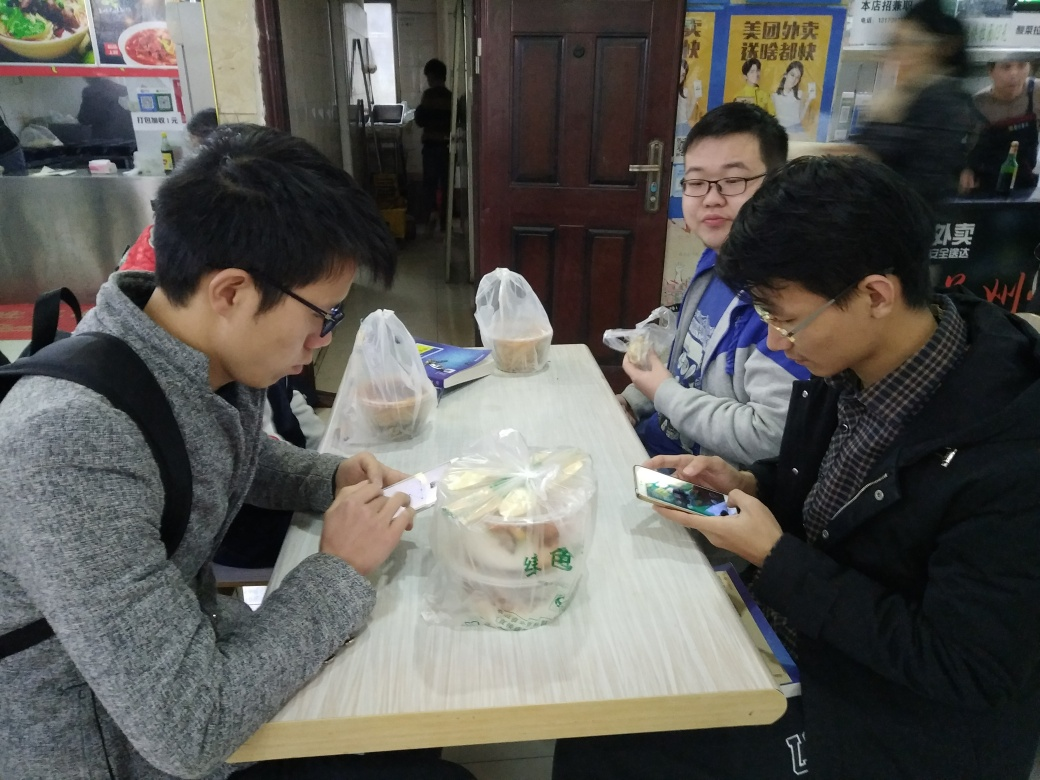Are the outlines of the main characters in the image clear? Yes, the outlines of the individuals in the image are distinct and clear, allowing us to easily discern the three main figures seated at the table as they engage in various activities, such as checking a mobile phone and handling food packaging. The clarity of these outlines provides an unobstructed view of the scene, contributing to the understanding of the depicted moment. 